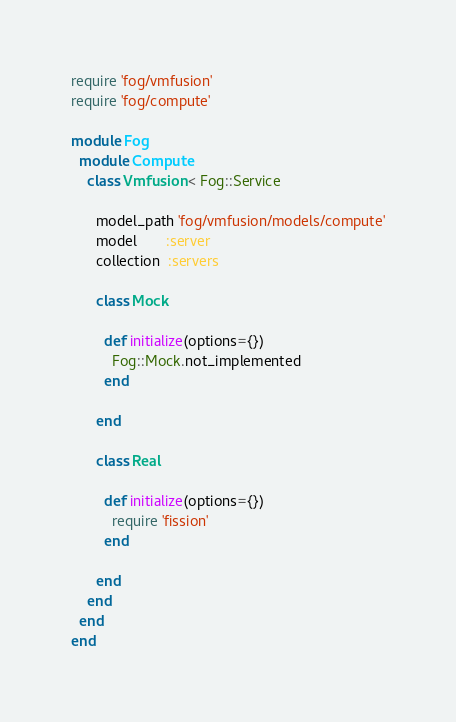<code> <loc_0><loc_0><loc_500><loc_500><_Ruby_>require 'fog/vmfusion'
require 'fog/compute'

module Fog
  module Compute
    class Vmfusion < Fog::Service

      model_path 'fog/vmfusion/models/compute'
      model       :server
      collection  :servers

      class Mock

        def initialize(options={})
          Fog::Mock.not_implemented
        end

      end

      class Real

        def initialize(options={})
          require 'fission'
        end

      end
    end
  end
end
</code> 